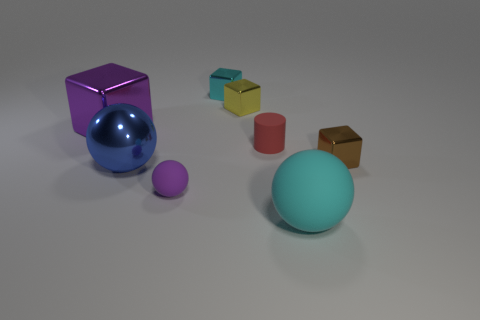Add 1 red cylinders. How many objects exist? 9 Subtract all yellow metallic cubes. How many cubes are left? 3 Subtract 2 cubes. How many cubes are left? 2 Subtract all cyan balls. How many balls are left? 2 Subtract all yellow cylinders. How many blue balls are left? 1 Subtract all purple things. Subtract all tiny cyan objects. How many objects are left? 5 Add 8 big purple shiny things. How many big purple shiny things are left? 9 Add 4 large cyan matte things. How many large cyan matte things exist? 5 Subtract 1 yellow cubes. How many objects are left? 7 Subtract all balls. How many objects are left? 5 